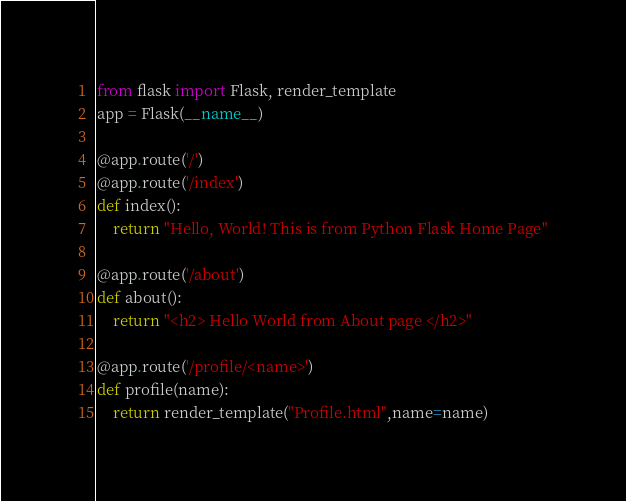<code> <loc_0><loc_0><loc_500><loc_500><_Python_>from flask import Flask, render_template
app = Flask(__name__)

@app.route('/')
@app.route('/index')
def index():
    return "Hello, World! This is from Python Flask Home Page"

@app.route('/about')
def about():
    return "<h2> Hello World from About page </h2>"

@app.route('/profile/<name>')
def profile(name):
    return render_template("Profile.html",name=name)
</code> 